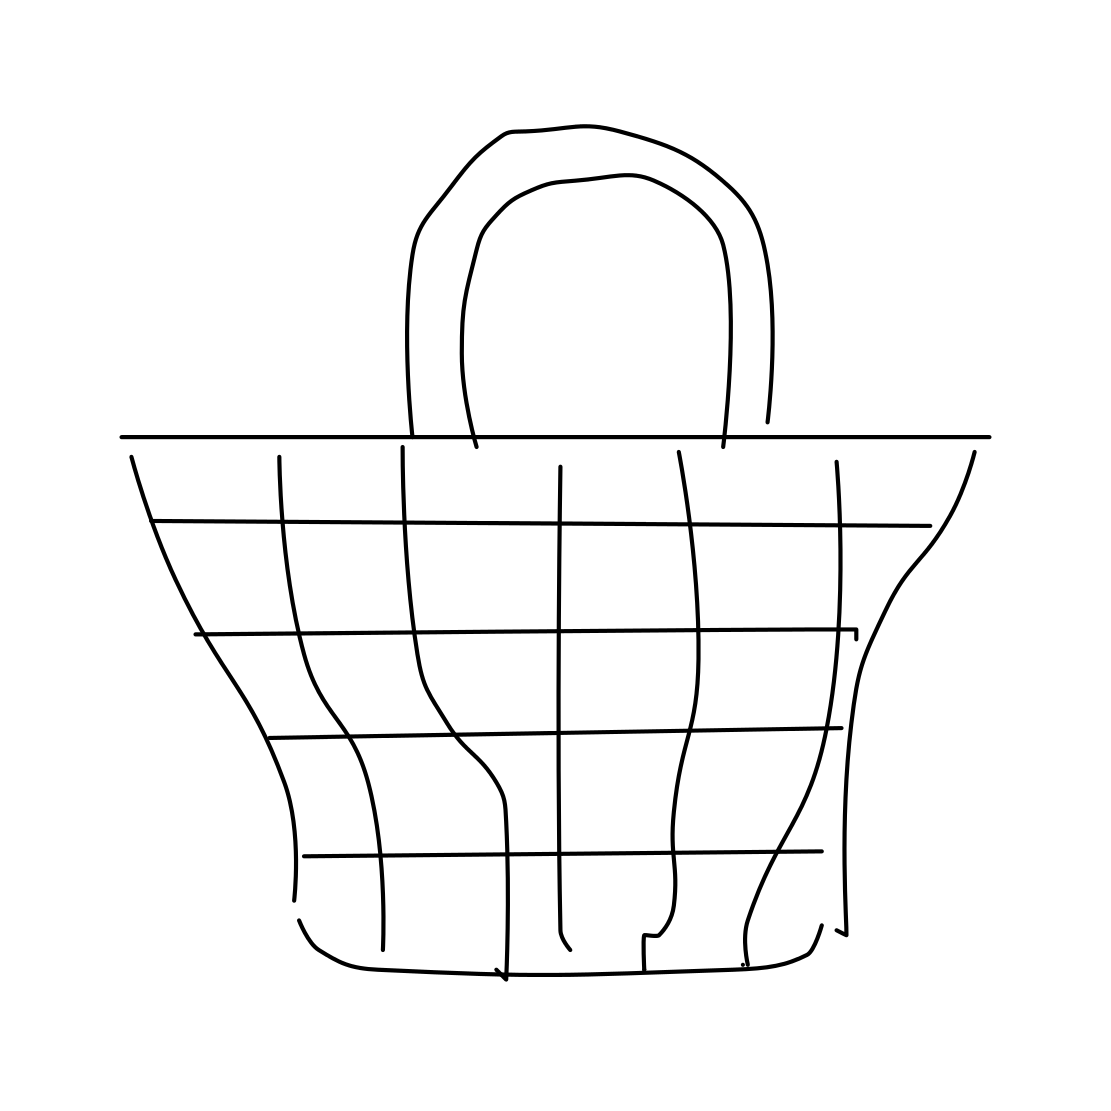Is this a comb in the image? No, the image does not show a comb. It appears to be a stylized drawing of a basket with a grid pattern that might visually resemble the teeth of a comb. 